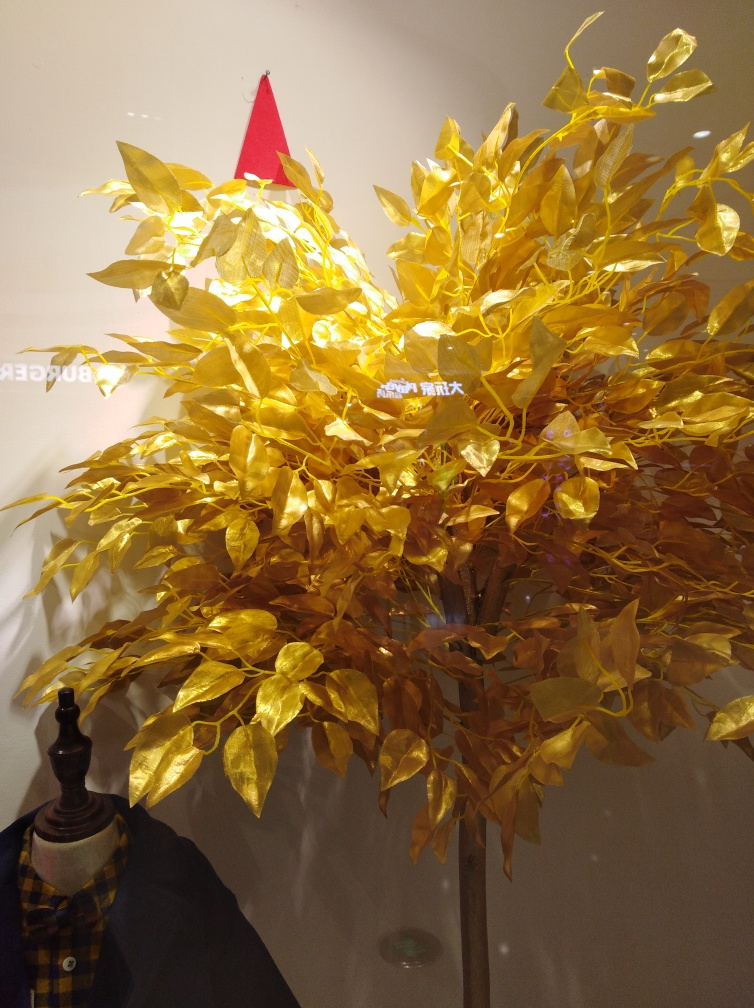What is unusual about this tree? This tree is not a typical living tree, but an artistic representation, possibly a sculpture or decoration. Its leaves are golden, giving it an ornamental look that implies it might be used for decorative purposes, possibly related to a celebration or a specific theme. Can you tell me more about the setting of this image? Certainly! The setting features a somewhat reflective surface, perhaps a glass window or a polished wall. There's a hint of a plaid garment and what looks like a mannequin below, suggesting this may be a retail or fashion display. A bright red cone, reminiscent of a Santa hat, sits atop the tree, adding a festive touch that might indicate a holiday theme. 